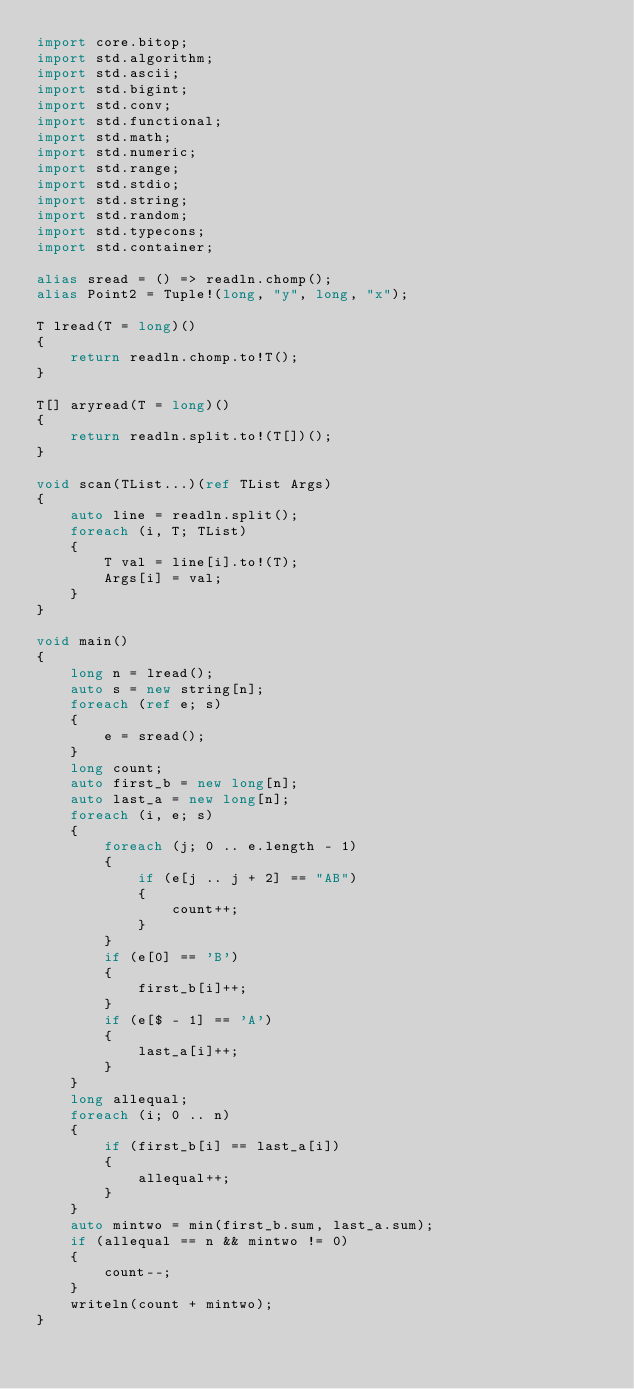<code> <loc_0><loc_0><loc_500><loc_500><_D_>import core.bitop;
import std.algorithm;
import std.ascii;
import std.bigint;
import std.conv;
import std.functional;
import std.math;
import std.numeric;
import std.range;
import std.stdio;
import std.string;
import std.random;
import std.typecons;
import std.container;

alias sread = () => readln.chomp();
alias Point2 = Tuple!(long, "y", long, "x");

T lread(T = long)()
{
    return readln.chomp.to!T();
}

T[] aryread(T = long)()
{
    return readln.split.to!(T[])();
}

void scan(TList...)(ref TList Args)
{
    auto line = readln.split();
    foreach (i, T; TList)
    {
        T val = line[i].to!(T);
        Args[i] = val;
    }
}

void main()
{
    long n = lread();
    auto s = new string[n];
    foreach (ref e; s)
    {
        e = sread();
    }
    long count;
    auto first_b = new long[n];
    auto last_a = new long[n];
    foreach (i, e; s)
    {
        foreach (j; 0 .. e.length - 1)
        {
            if (e[j .. j + 2] == "AB")
            {
                count++;
            }
        }
        if (e[0] == 'B')
        {
            first_b[i]++;
        }
        if (e[$ - 1] == 'A')
        {
            last_a[i]++;
        }
    }
    long allequal;
    foreach (i; 0 .. n)
    {
        if (first_b[i] == last_a[i])
        {
            allequal++;
        }
    }
    auto mintwo = min(first_b.sum, last_a.sum);
    if (allequal == n && mintwo != 0)
    {
        count--;
    }
    writeln(count + mintwo);
}</code> 